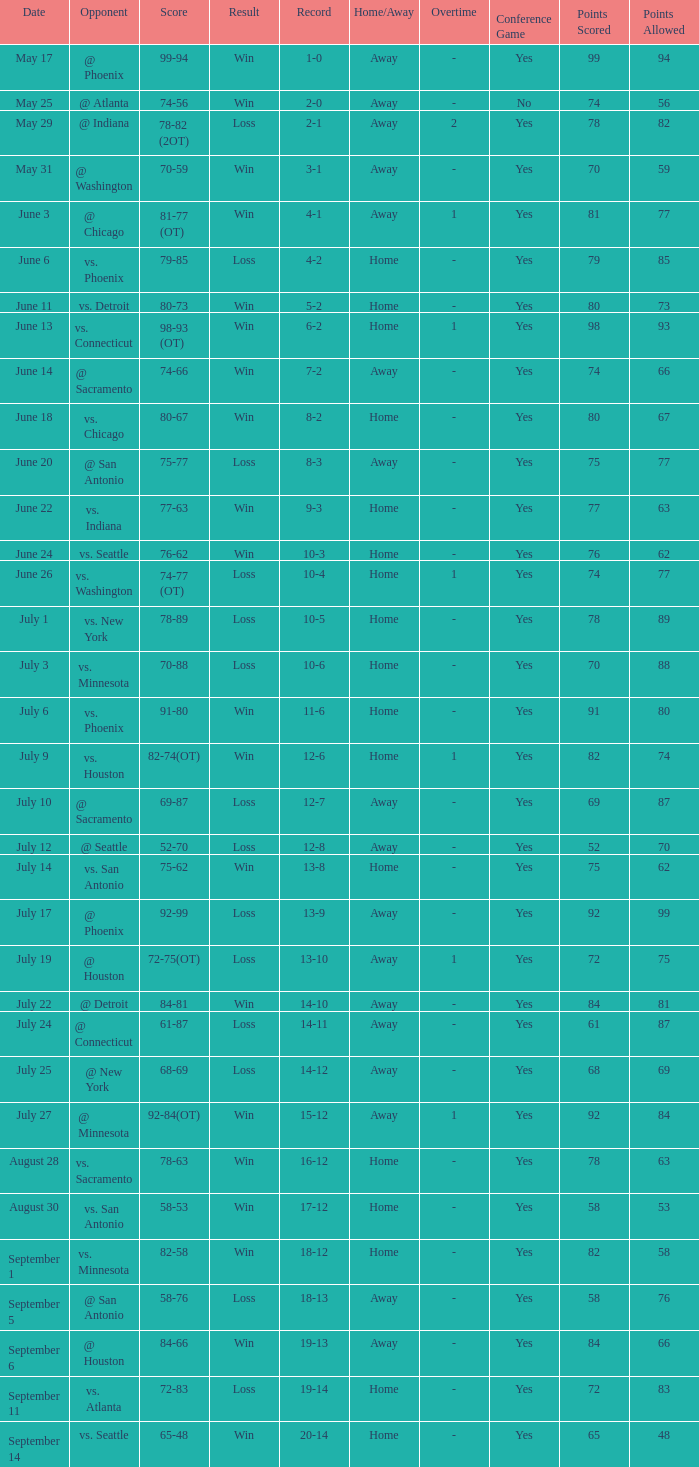What is the Record of the game with a Score of 65-48? 20-14. 